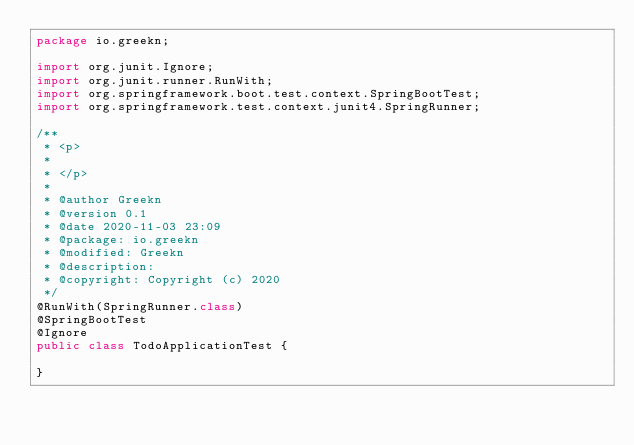Convert code to text. <code><loc_0><loc_0><loc_500><loc_500><_Java_>package io.greekn;

import org.junit.Ignore;
import org.junit.runner.RunWith;
import org.springframework.boot.test.context.SpringBootTest;
import org.springframework.test.context.junit4.SpringRunner;

/**
 * <p>
 *
 * </p>
 *
 * @author Greekn
 * @version 0.1
 * @date 2020-11-03 23:09
 * @package: io.greekn
 * @modified: Greekn
 * @description:
 * @copyright: Copyright (c) 2020
 */
@RunWith(SpringRunner.class)
@SpringBootTest
@Ignore
public class TodoApplicationTest {

}</code> 